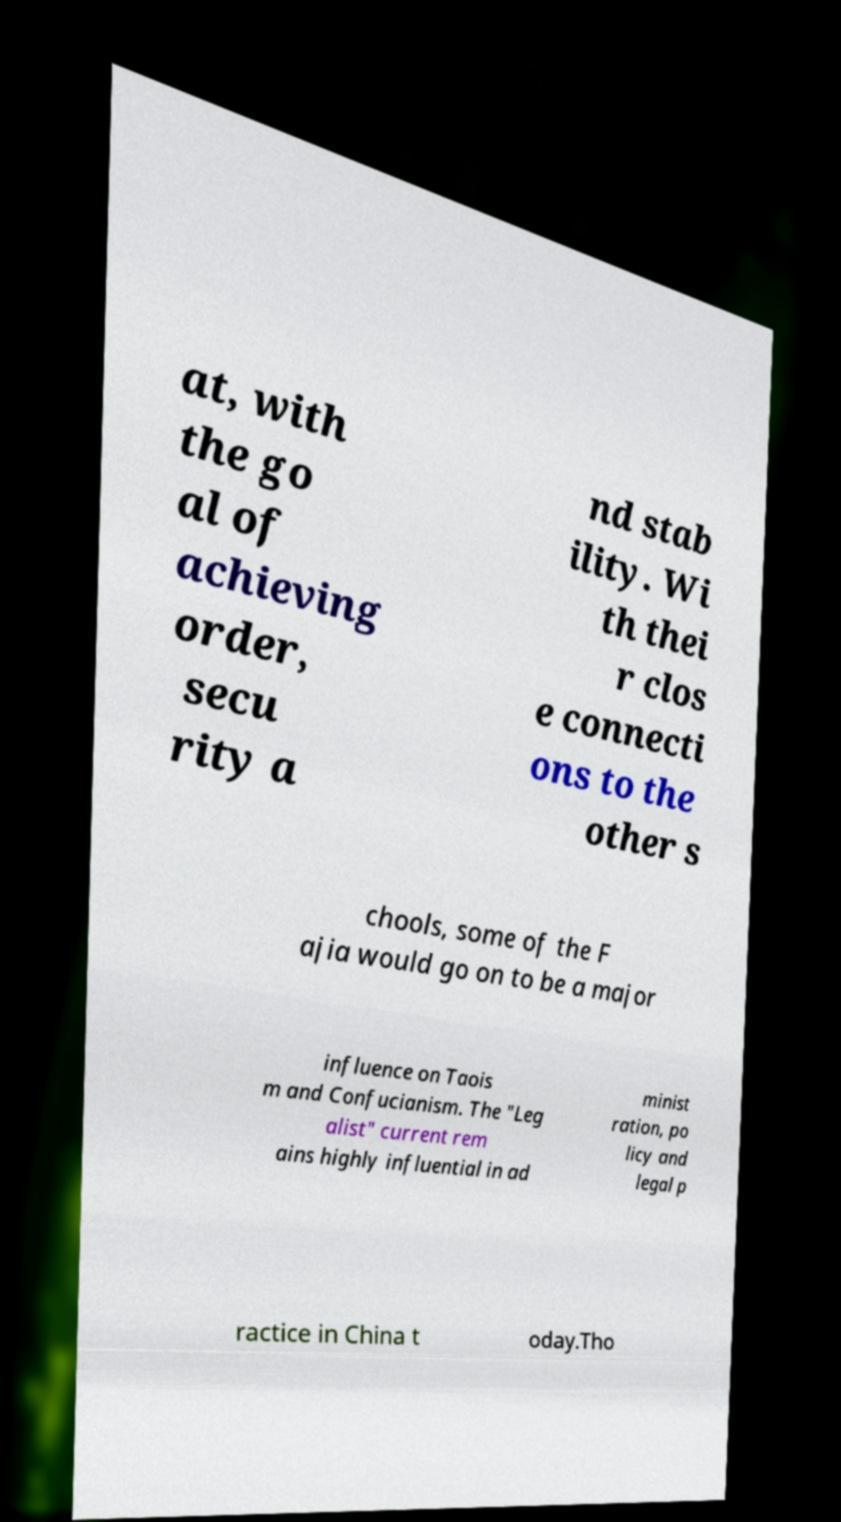Could you extract and type out the text from this image? at, with the go al of achieving order, secu rity a nd stab ility. Wi th thei r clos e connecti ons to the other s chools, some of the F ajia would go on to be a major influence on Taois m and Confucianism. The "Leg alist" current rem ains highly influential in ad minist ration, po licy and legal p ractice in China t oday.Tho 